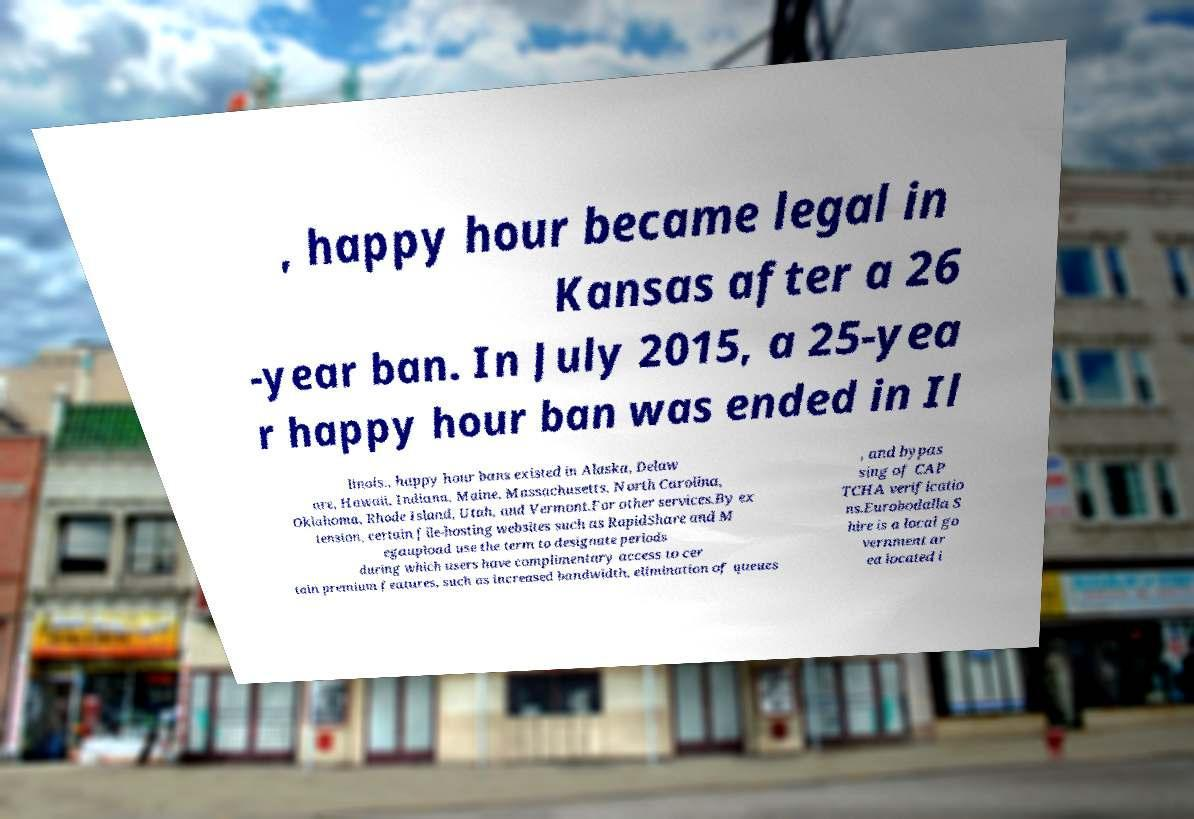What messages or text are displayed in this image? I need them in a readable, typed format. , happy hour became legal in Kansas after a 26 -year ban. In July 2015, a 25-yea r happy hour ban was ended in Il linois., happy hour bans existed in Alaska, Delaw are, Hawaii, Indiana, Maine, Massachusetts, North Carolina, Oklahoma, Rhode Island, Utah, and Vermont.For other services.By ex tension, certain file-hosting websites such as RapidShare and M egaupload use the term to designate periods during which users have complimentary access to cer tain premium features, such as increased bandwidth, elimination of queues , and bypas sing of CAP TCHA verificatio ns.Eurobodalla S hire is a local go vernment ar ea located i 